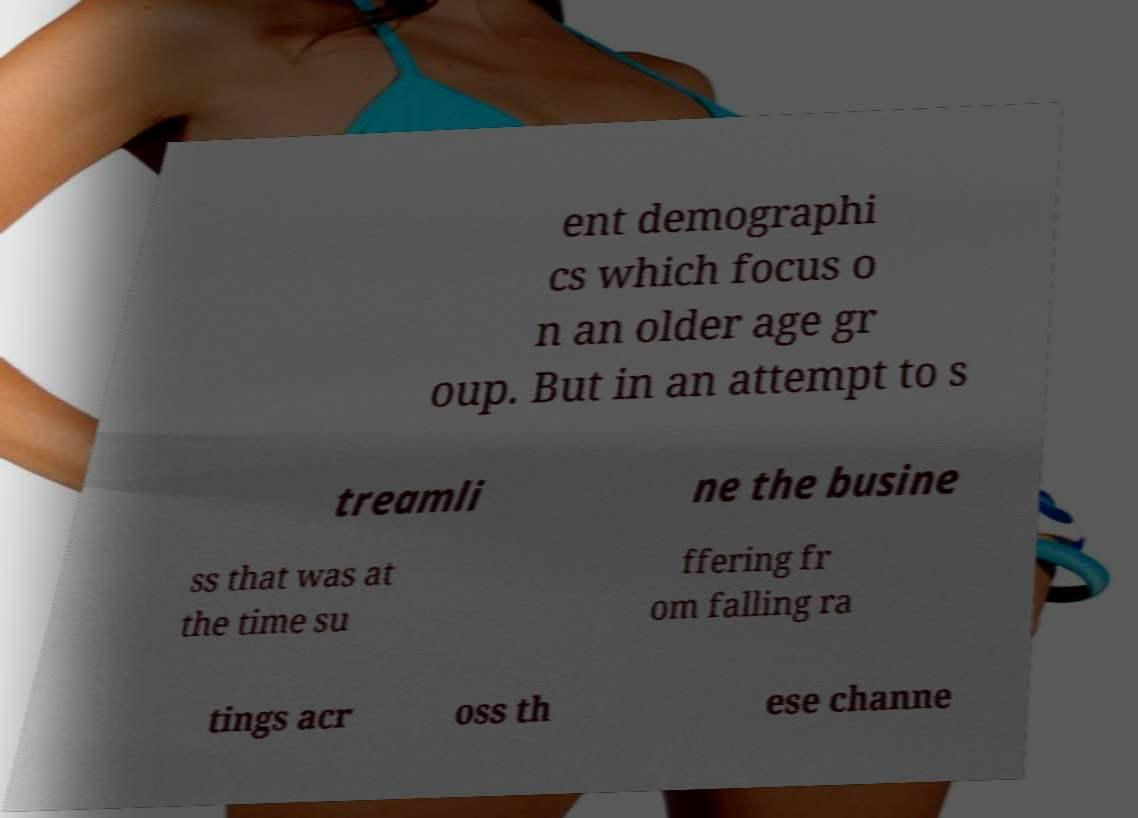I need the written content from this picture converted into text. Can you do that? ent demographi cs which focus o n an older age gr oup. But in an attempt to s treamli ne the busine ss that was at the time su ffering fr om falling ra tings acr oss th ese channe 